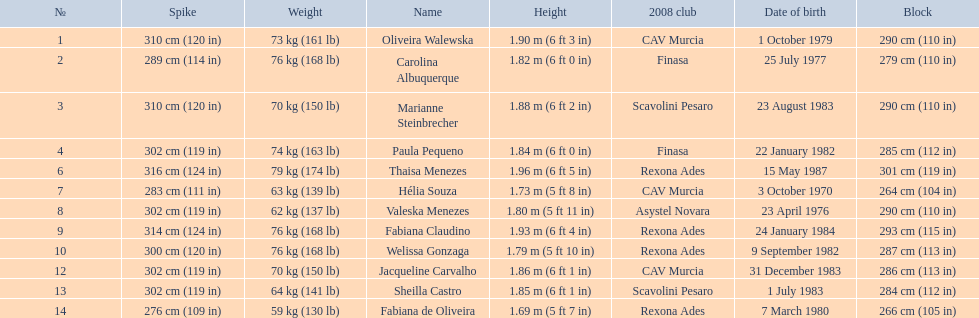Who is the next tallest player after thaisa menezes? Fabiana Claudino. 